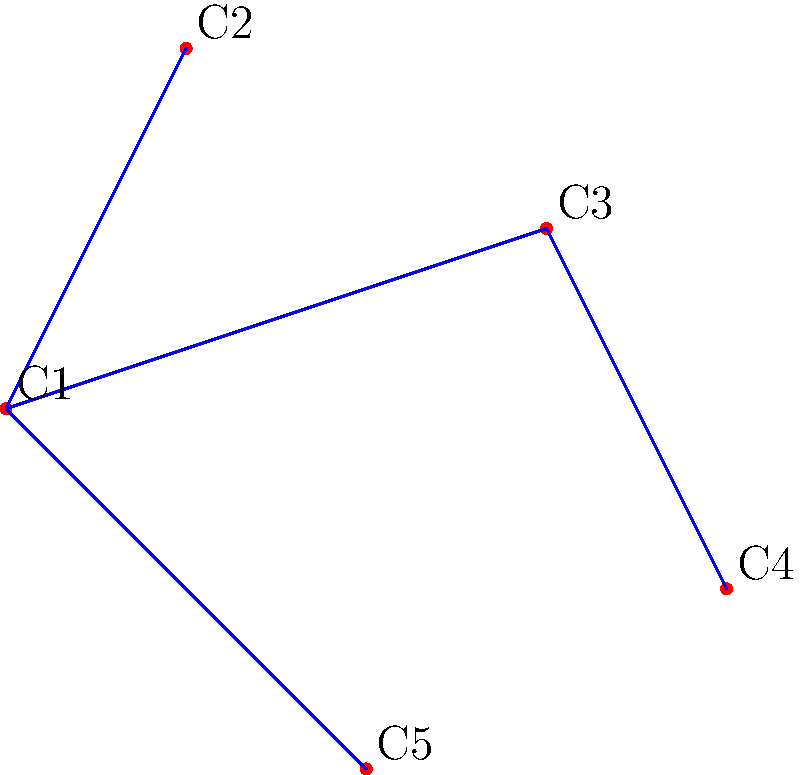As a retired police officer involved in community relations, you're tasked with optimizing the communication network between five community centers (C1, C2, C3, C4, C5) in your city. The goal is to ensure all centers are connected while minimizing the total number of direct connections. Based on the diagram, what is the minimum number of connections needed to link all community centers? To solve this problem, we need to understand the concept of a minimum spanning tree in graph theory. Here's a step-by-step explanation:

1. In the given diagram, we have 5 vertices (community centers) labeled C1 to C5.

2. The minimum number of connections needed to link all vertices in a graph with $n$ vertices is always $n-1$. This creates a tree structure that spans all vertices without forming any cycles.

3. In our case, we have 5 vertices, so the minimum number of connections needed is:

   $$ \text{Minimum connections} = n - 1 = 5 - 1 = 4 $$

4. We can verify this by looking at the blue lines in the diagram, which represent the minimum spanning tree:
   - C1 is connected to C2
   - C1 is connected to C3
   - C1 is connected to C5
   - C3 is connected to C4

5. This configuration ensures that all community centers are connected, either directly or indirectly, using the minimum number of connections.

6. Adding any more connections would create redundant paths or cycles, which are not necessary for basic connectivity.

This solution ensures efficient communication between all community centers while minimizing infrastructure costs, which aligns with the goal of effective community relations and resource management.
Answer: 4 connections 